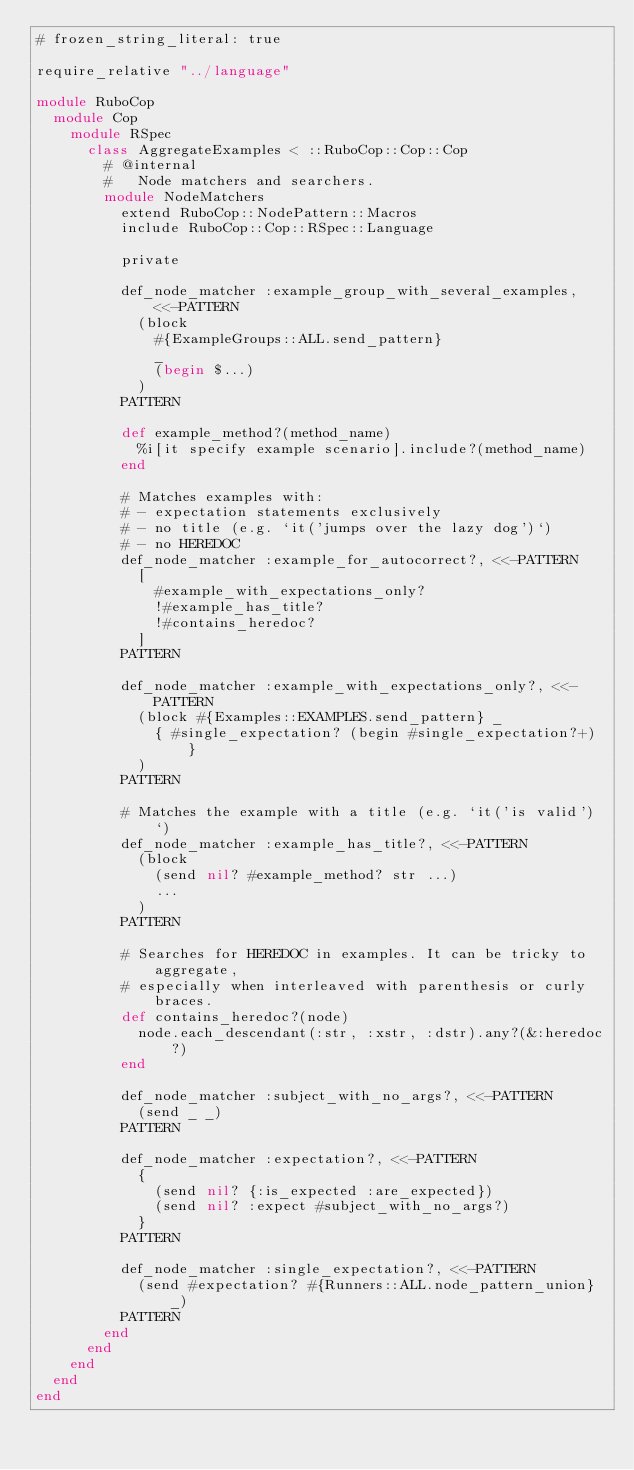<code> <loc_0><loc_0><loc_500><loc_500><_Ruby_># frozen_string_literal: true

require_relative "../language"

module RuboCop
  module Cop
    module RSpec
      class AggregateExamples < ::RuboCop::Cop::Cop
        # @internal
        #   Node matchers and searchers.
        module NodeMatchers
          extend RuboCop::NodePattern::Macros
          include RuboCop::Cop::RSpec::Language

          private

          def_node_matcher :example_group_with_several_examples, <<-PATTERN
            (block
              #{ExampleGroups::ALL.send_pattern}
              _
              (begin $...)
            )
          PATTERN

          def example_method?(method_name)
            %i[it specify example scenario].include?(method_name)
          end

          # Matches examples with:
          # - expectation statements exclusively
          # - no title (e.g. `it('jumps over the lazy dog')`)
          # - no HEREDOC
          def_node_matcher :example_for_autocorrect?, <<-PATTERN
            [
              #example_with_expectations_only?
              !#example_has_title?
              !#contains_heredoc?
            ]
          PATTERN

          def_node_matcher :example_with_expectations_only?, <<-PATTERN
            (block #{Examples::EXAMPLES.send_pattern} _
              { #single_expectation? (begin #single_expectation?+) }
            )
          PATTERN

          # Matches the example with a title (e.g. `it('is valid')`)
          def_node_matcher :example_has_title?, <<-PATTERN
            (block
              (send nil? #example_method? str ...)
              ...
            )
          PATTERN

          # Searches for HEREDOC in examples. It can be tricky to aggregate,
          # especially when interleaved with parenthesis or curly braces.
          def contains_heredoc?(node)
            node.each_descendant(:str, :xstr, :dstr).any?(&:heredoc?)
          end

          def_node_matcher :subject_with_no_args?, <<-PATTERN
            (send _ _)
          PATTERN

          def_node_matcher :expectation?, <<-PATTERN
            {
              (send nil? {:is_expected :are_expected})
              (send nil? :expect #subject_with_no_args?)
            }
          PATTERN

          def_node_matcher :single_expectation?, <<-PATTERN
            (send #expectation? #{Runners::ALL.node_pattern_union} _)
          PATTERN
        end
      end
    end
  end
end
</code> 